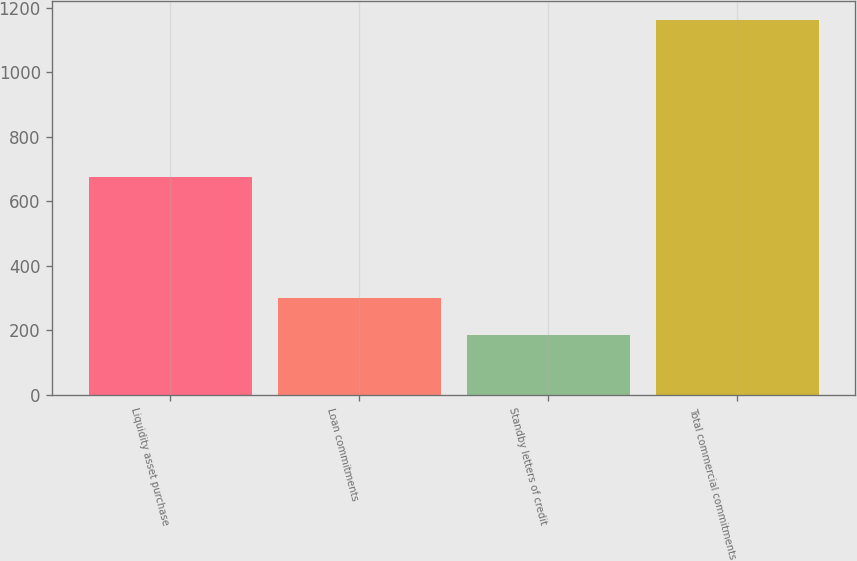Convert chart. <chart><loc_0><loc_0><loc_500><loc_500><bar_chart><fcel>Liquidity asset purchase<fcel>Loan commitments<fcel>Standby letters of credit<fcel>Total commercial commitments<nl><fcel>675<fcel>300<fcel>187<fcel>1162<nl></chart> 